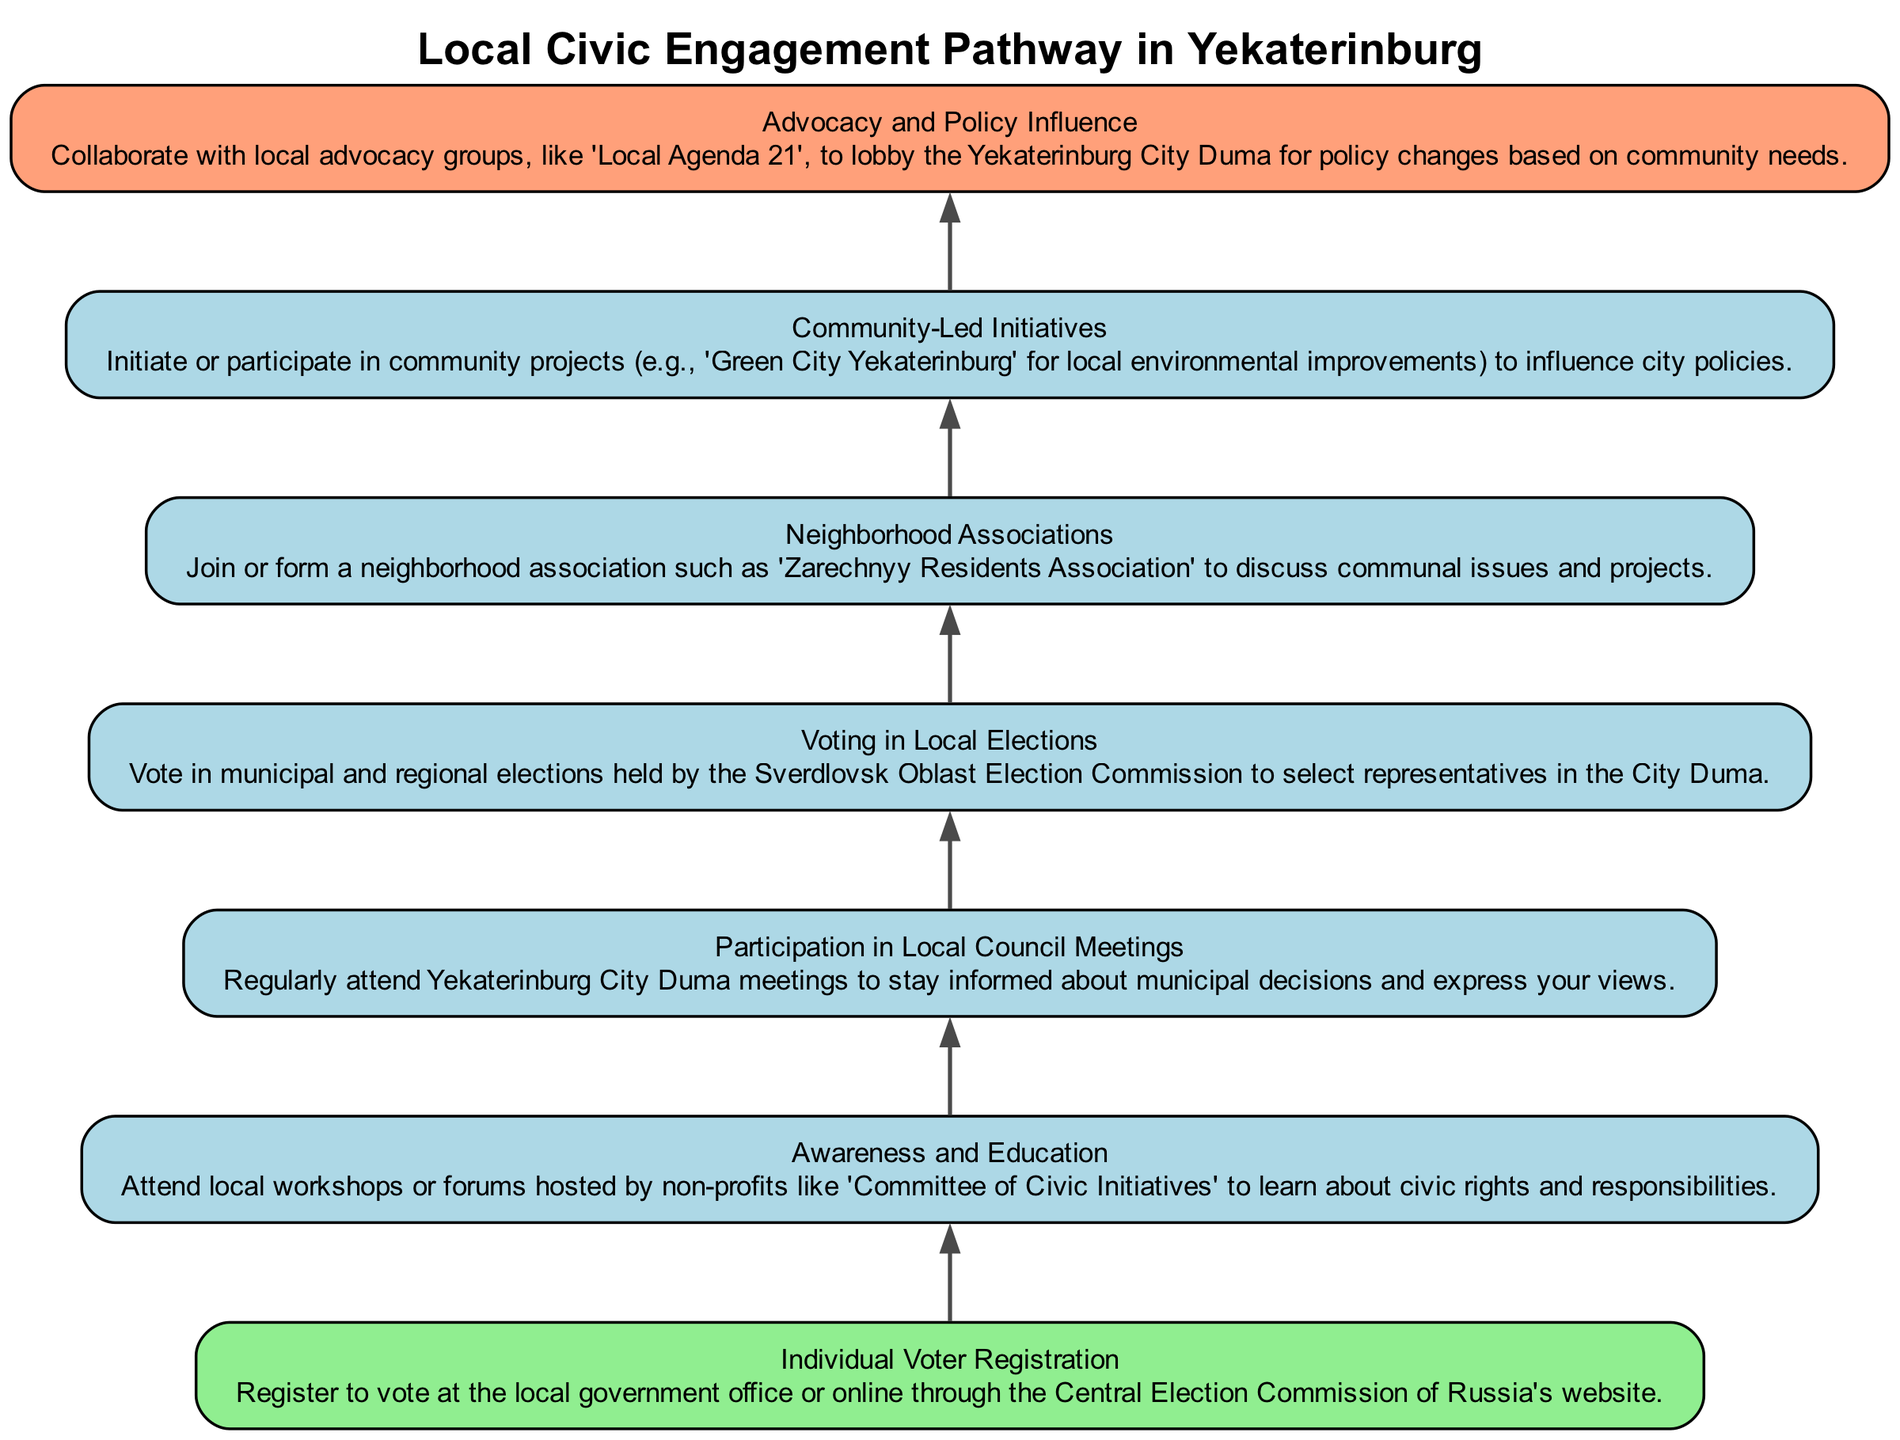What is the first step in the pathway? The first step is "Individual Voter Registration," which is positioned at the bottom of the diagram. This indicates the initiation point of civic engagement.
Answer: Individual Voter Registration How many steps are in the diagram? By counting the nodes representing each step from "Individual Voter Registration" to "Advocacy and Policy Influence," there are seven distinct steps included in the pathway.
Answer: 7 What is the last step described in the flow? The last step in the flow is "Advocacy and Policy Influence," which is located at the top of the diagram, indicating it is the ultimate goal within the pathway to impact city policies.
Answer: Advocacy and Policy Influence Which step involves community projects? The step that specifically mentions community projects is "Community-Led Initiatives," identified in the flow as involving participation in local initiatives that can influence city policies.
Answer: Community-Led Initiatives How does "Participation in Local Council Meetings" relate to "Voting in Local Elections"? The relationship is sequential; "Participation in Local Council Meetings" must occur before "Voting in Local Elections," indicating that being informed through council meetings is a prerequisite for making informed voting decisions.
Answer: Sequentially related What is the purpose of "Awareness and Education"? The purpose stated for this step is to "attend local workshops or forums" to learn about civic rights and responsibilities, which serves as a foundational knowledge base for engagement.
Answer: To learn about civic rights and responsibilities Which organization is mentioned in the "Awareness and Education" step? The organization mentioned in this step is "Committee of Civic Initiatives," which provides workshops and forums for civic education.
Answer: Committee of Civic Initiatives What type of associations are formed in the pathway? The produced associations are "Neighborhood Associations," which are formed to discuss communal issues and facilitate local engagement activities.
Answer: Neighborhood Associations What step follows "Voting in Local Elections"? "Neighborhood Associations" follows "Voting in Local Elections," indicating a transition from the act of voting to active community engagement through forming or joining local associations.
Answer: Neighborhood Associations 